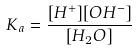Convert formula to latex. <formula><loc_0><loc_0><loc_500><loc_500>K _ { a } = \frac { [ H ^ { + } ] [ O H ^ { - } ] } { [ H _ { 2 } O ] }</formula> 